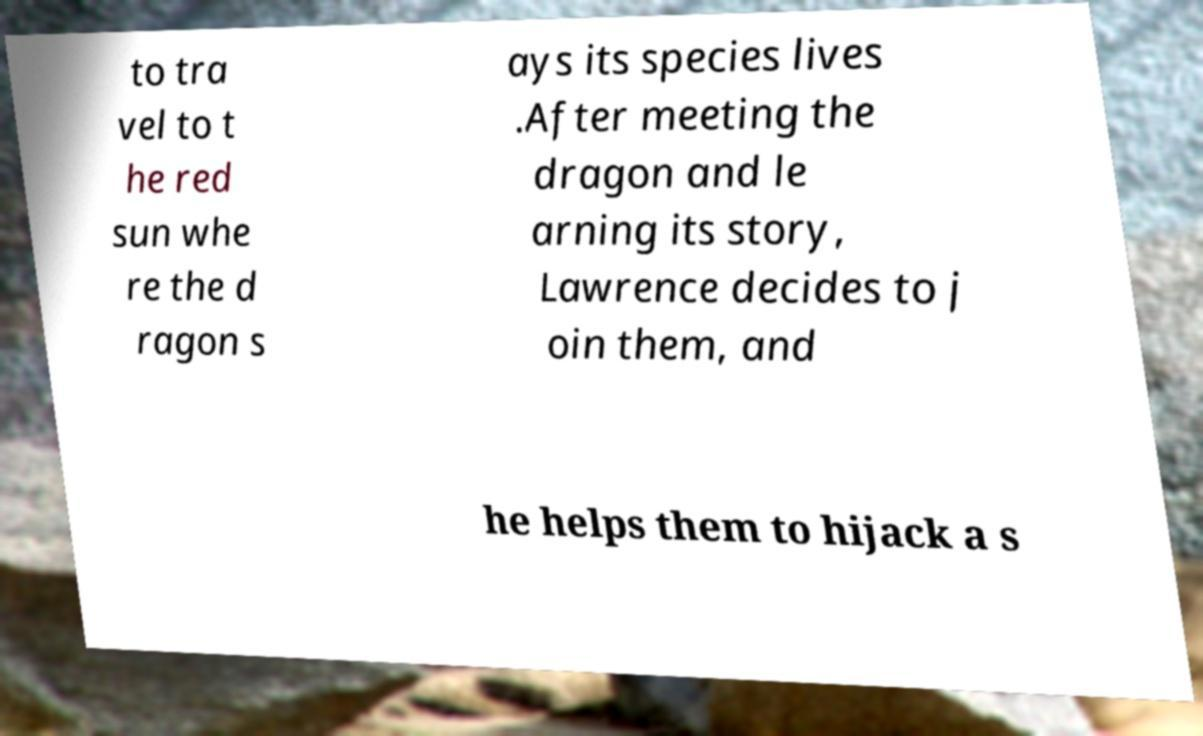Could you extract and type out the text from this image? to tra vel to t he red sun whe re the d ragon s ays its species lives .After meeting the dragon and le arning its story, Lawrence decides to j oin them, and he helps them to hijack a s 